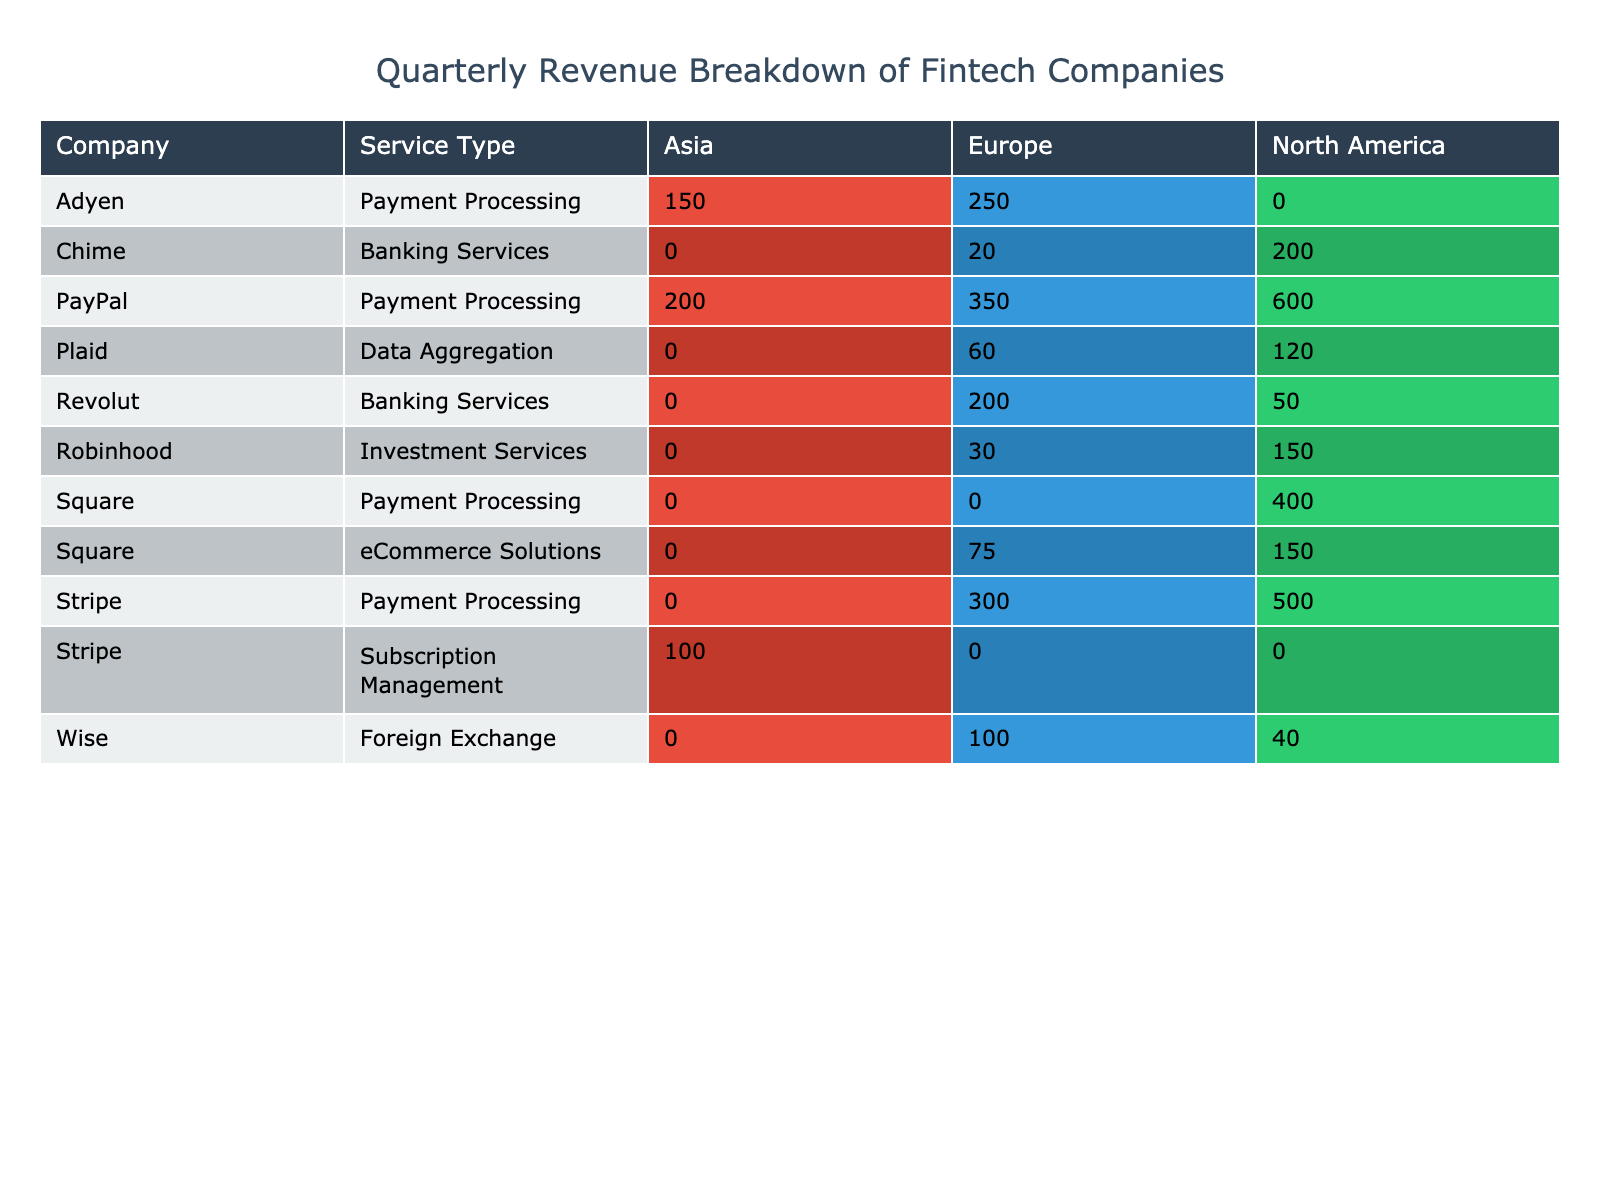What is the total revenue generated by PayPal in North America? In the table, PayPal's revenue in North America for Q1 2023 is listed as 600 million USD. This is the only revenue entry for PayPal in that region.
Answer: 600 million USD Which company generates the highest revenue in Europe for Q1 2023? To determine this, we look at all companies' revenues in the Europe column. The values are: PayPal 350, Square (75), Stripe (300), Adyen (250), Revolut (200), and Chime (20). PayPal has the highest revenue at 350 million USD.
Answer: PayPal What is the combined revenue from Payment Processing services across all regions for Square and Stripe? First, we retrieve the revenue for Square from the Payments column, which includes 400 (North America) and 0 (Europe, Asia). For Stripe, it includes 500 (North America), 300 (Europe), and 0 (Asia) and the subscription management service is separately added from Asia as 100 USD in full. Therefore, the totals are 400 + 0 + 500 + 300 = 1200 million USD.
Answer: 1200 million USD Does Wise provide services in Asia? Looking at the table, Wise has revenues listed in Europe and North America, but there is no entry for Asia, indicating they do not operate there.
Answer: No What is the average revenue generated by Banking Services across all regions for Revolut and Chime? For Revolut, the revenues are 200 (Europe) and 50 (North America) giving a total of 250 million USD. For Chime, the revenues are 200 (North America) and 20 (Europe), totaling 220 million USD. To find the average, we sum these totals (250 + 220 = 470) and divide by the number of companies (2), yielding an average of 235 million USD.
Answer: 235 million USD What is the difference in revenue between the top two companies in Asia? The table shows that Stripe has generated 100 million USD in Asia from subscription management and Adyen with 150 million USD from payment processing. The difference between them is 150 - 100 = 50 million USD, making Adyen the top with a higher revenue.
Answer: 50 million USD Which service type contributes the least to total revenue in Europe during Q1 2023? Summing revenues in Europe for each service type: Payment Processing (350 PayPal + 75 Square + 300 Stripe + 250 Adyen + 200 Revolut + 20 Chime = 1275 million USD), Banking Services (200 Revolut + 50 Chime = 250 million USD), Investment Services (30 Robinhood = 30 million USD), Foreign Exchange (100 Wise = 100 million USD), and Data Aggregation (60 Plaid = 60 million USD). The smallest contribution is from Investment Services with 30 million USD.
Answer: Investment Services What revenue does Plaid generate in North America compared to Europe? The table shows Plaid earns 120 million USD in North America and 60 million USD in Europe. Comparing the two gives 120 (NA) - 60 (Europe) = 60 million USD, indicating a significant difference favoring North America.
Answer: 60 million USD 